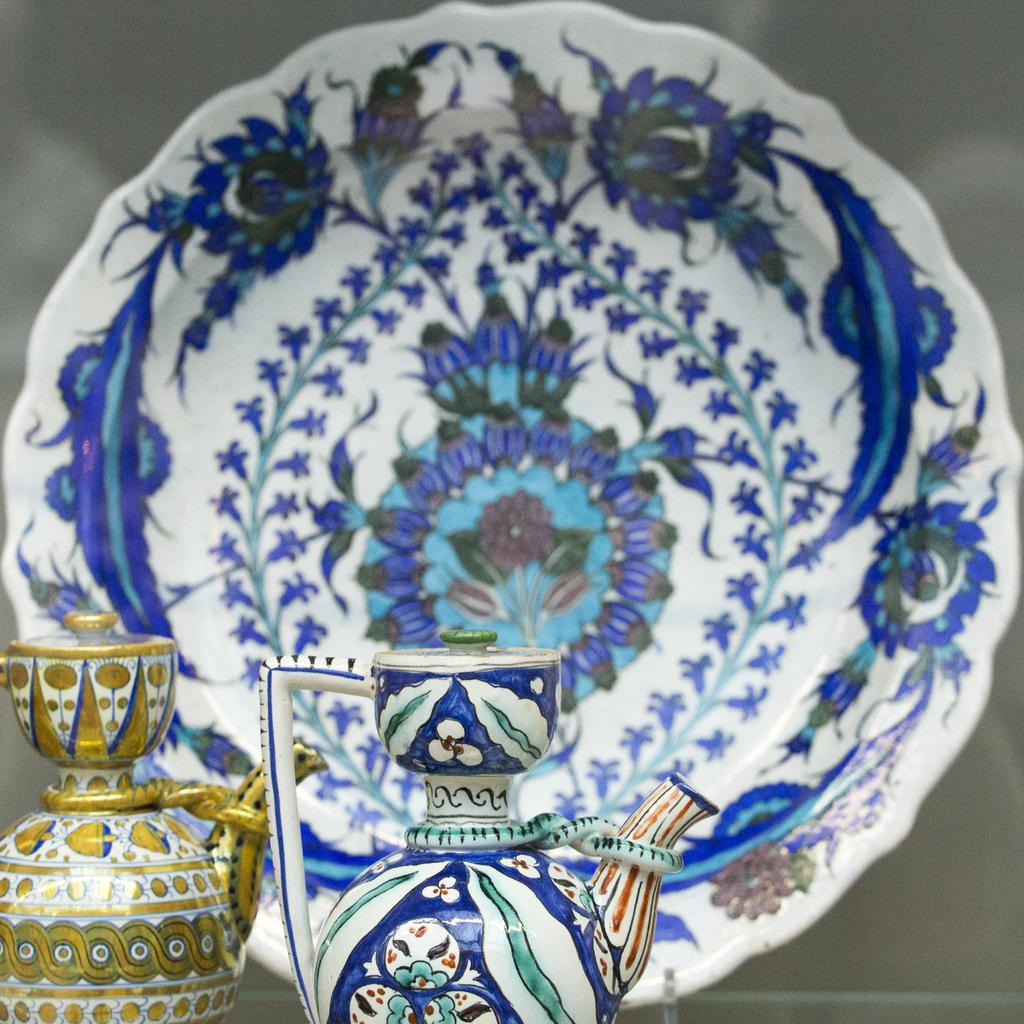What objects are present on the table in the image? There are jars and a plate on the table in the image. What might be the purpose of the jars and plate? The jars and plate might be used for serving or storing food or other items. Where are the jars and plate located in the image? The jars and plate are placed on a table in the image. What type of education is being taught in the building visible in the image? There is no building visible in the image, nor any indication of education being taught in the image. 